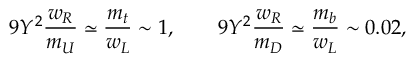<formula> <loc_0><loc_0><loc_500><loc_500>9 Y ^ { 2 } { \frac { w _ { R } } { m _ { U } } } \simeq { \frac { m _ { t } } { w _ { L } } } \sim 1 , \quad 9 Y ^ { 2 } { \frac { w _ { R } } { m _ { D } } } \simeq { \frac { m _ { b } } { w _ { L } } } \sim 0 . 0 2 ,</formula> 